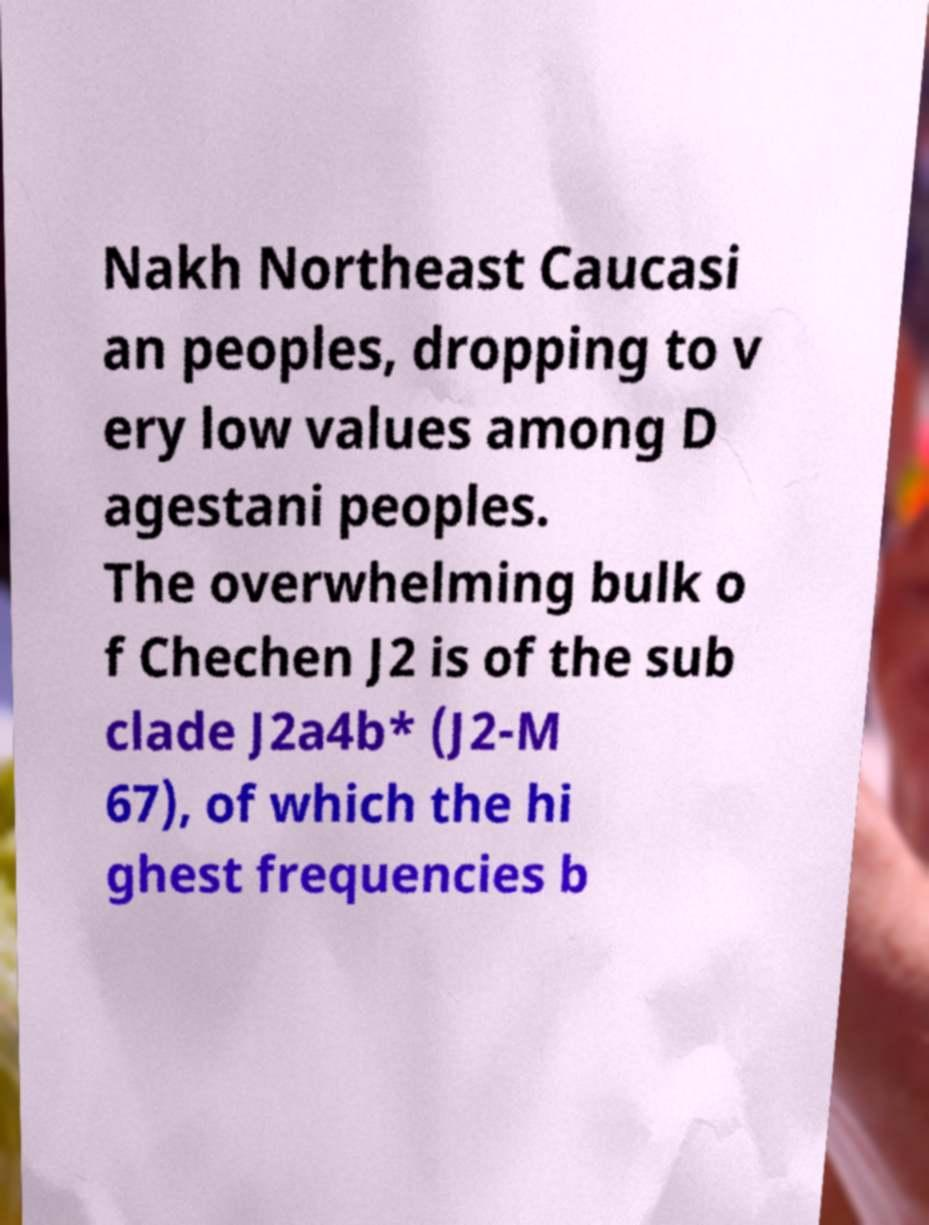There's text embedded in this image that I need extracted. Can you transcribe it verbatim? Nakh Northeast Caucasi an peoples, dropping to v ery low values among D agestani peoples. The overwhelming bulk o f Chechen J2 is of the sub clade J2a4b* (J2-M 67), of which the hi ghest frequencies b 